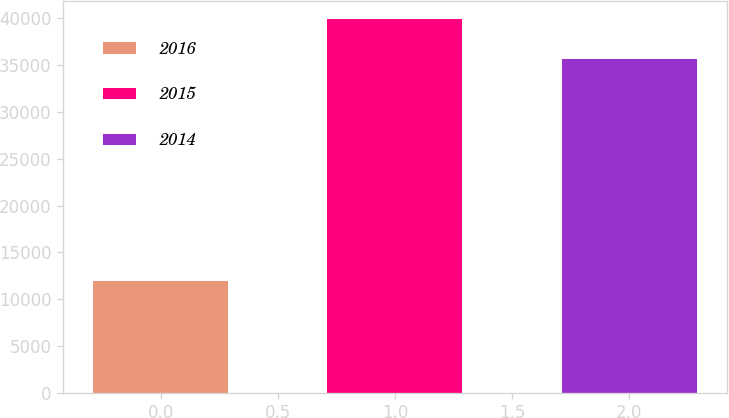Convert chart to OTSL. <chart><loc_0><loc_0><loc_500><loc_500><bar_chart><fcel>2016<fcel>2015<fcel>2014<nl><fcel>11924<fcel>39895<fcel>35663<nl></chart> 